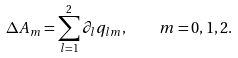<formula> <loc_0><loc_0><loc_500><loc_500>\Delta A _ { m } = \sum _ { l = 1 } ^ { 2 } \partial _ { l } q _ { l m } , \quad m = 0 , 1 , 2 .</formula> 